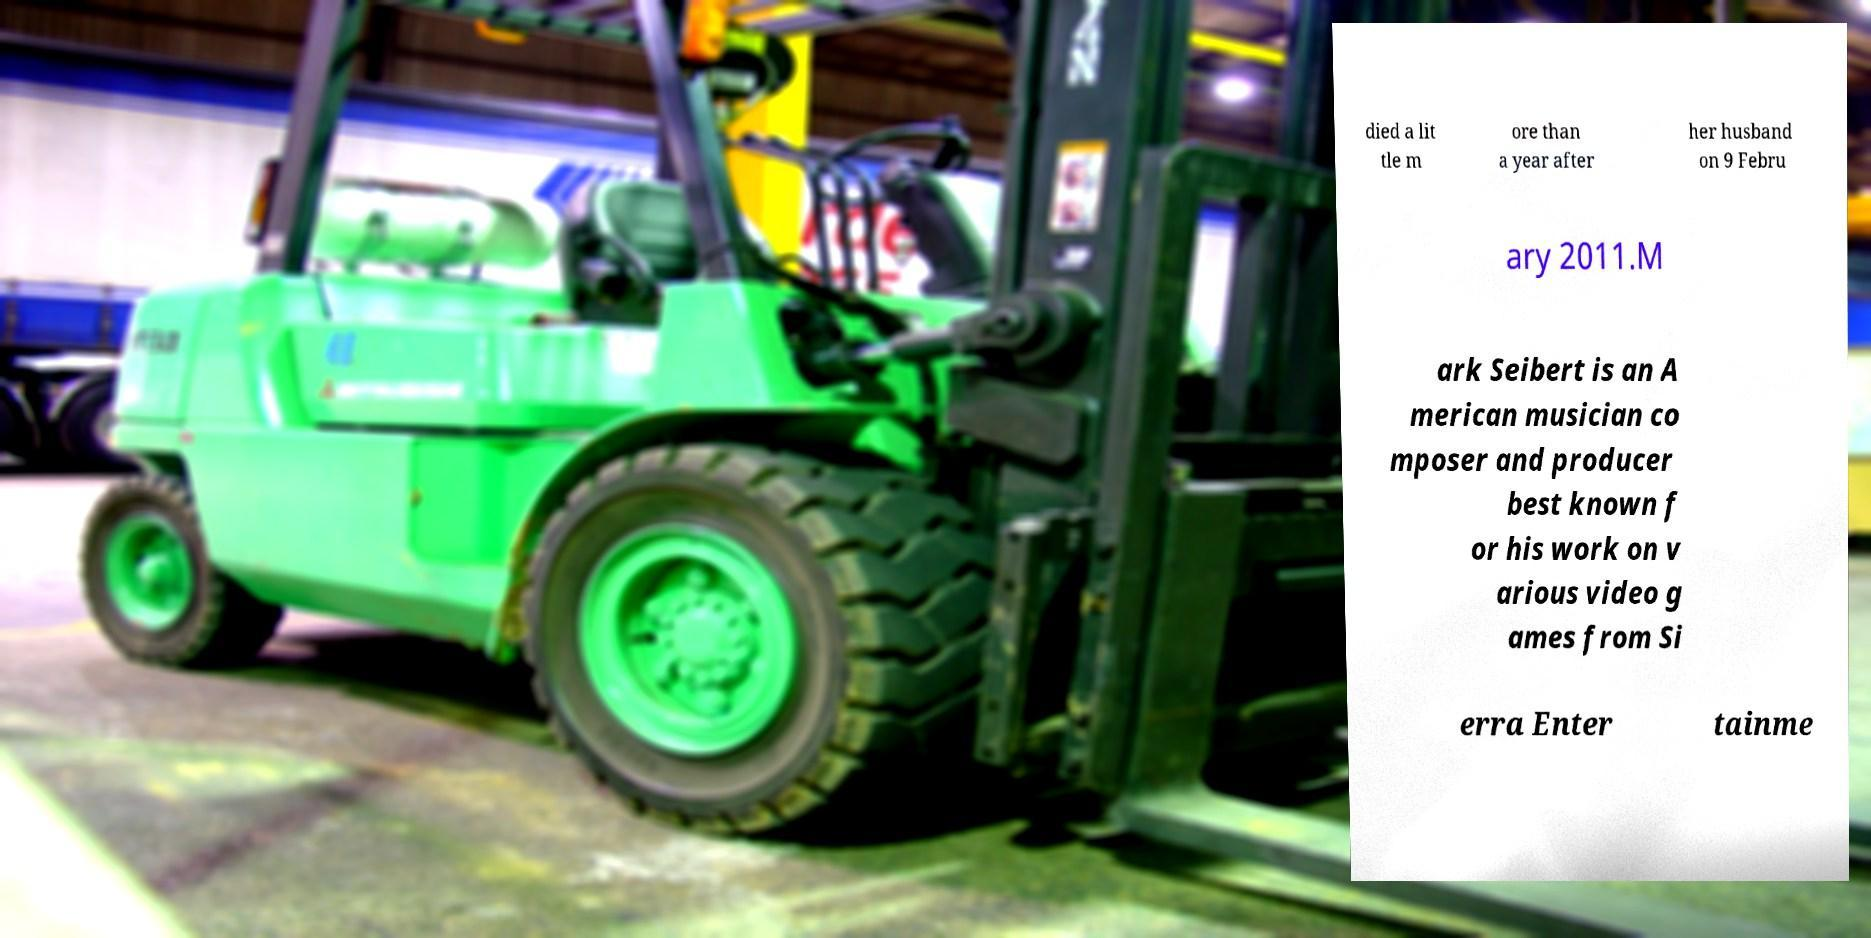Could you assist in decoding the text presented in this image and type it out clearly? died a lit tle m ore than a year after her husband on 9 Febru ary 2011.M ark Seibert is an A merican musician co mposer and producer best known f or his work on v arious video g ames from Si erra Enter tainme 